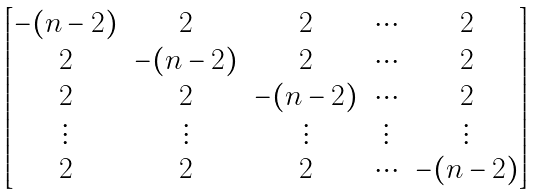Convert formula to latex. <formula><loc_0><loc_0><loc_500><loc_500>\begin{bmatrix} - ( n - 2 ) & 2 & 2 & \cdots & 2 \\ 2 & - ( n - 2 ) & 2 & \cdots & 2 \\ 2 & 2 & - ( n - 2 ) & \cdots & 2 \\ \vdots & \vdots & \vdots & \vdots & \vdots \\ 2 & 2 & 2 & \cdots & - ( n - 2 ) \end{bmatrix}</formula> 